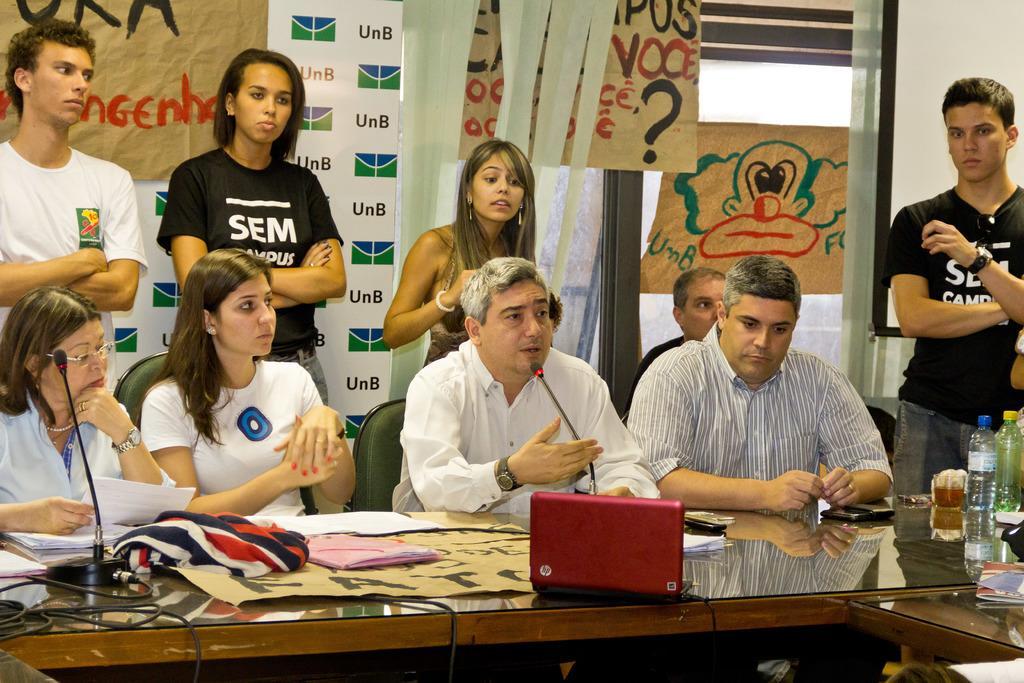How would you summarize this image in a sentence or two? In front of the picture, we see two men and two women are sitting. In front of them, we see a table on which microphones, cloth, diapers, water bottles, a glass containing liquid and mobile phones are placed. Behind them, we see people are standing. Behind them, we see a board in white color with some text written. Beside that, we see a sheet or a banner with some text written on it. The man on the right side who is wearing black T-shirt is standing. Behind him, we see a projector screen. Beside that, we see a glass door. 